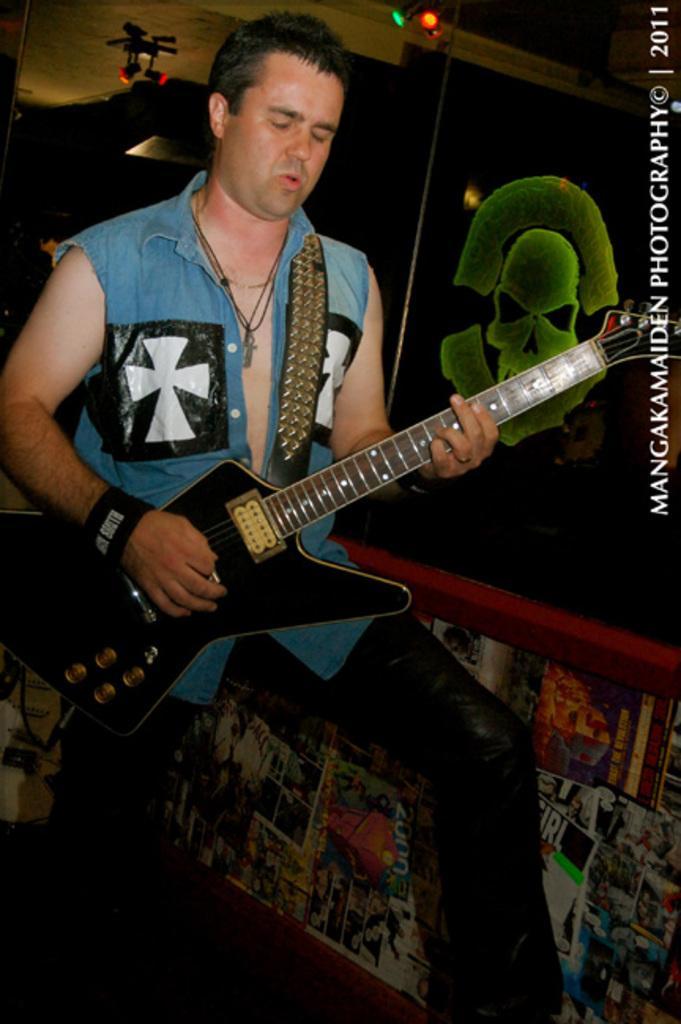How would you summarize this image in a sentence or two? This image consists of a man playing a guitar. He is wearing a blue shirt. In the background, there are posters pasted on the wall. At the top, there is a roof. 